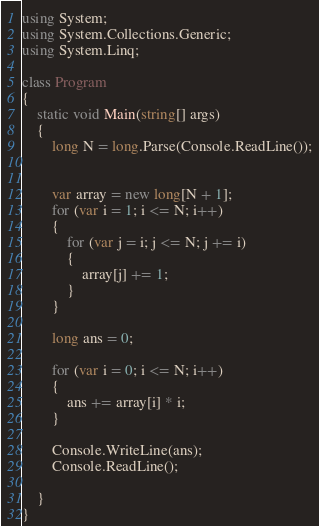<code> <loc_0><loc_0><loc_500><loc_500><_C#_>using System;
using System.Collections.Generic;
using System.Linq;

class Program
{
    static void Main(string[] args)
    {
        long N = long.Parse(Console.ReadLine());


        var array = new long[N + 1];
        for (var i = 1; i <= N; i++)
        {
            for (var j = i; j <= N; j += i)
            {
                array[j] += 1;
            }
        }

        long ans = 0;

        for (var i = 0; i <= N; i++)
        {
            ans += array[i] * i;
        }

        Console.WriteLine(ans);
        Console.ReadLine();

    }
}</code> 